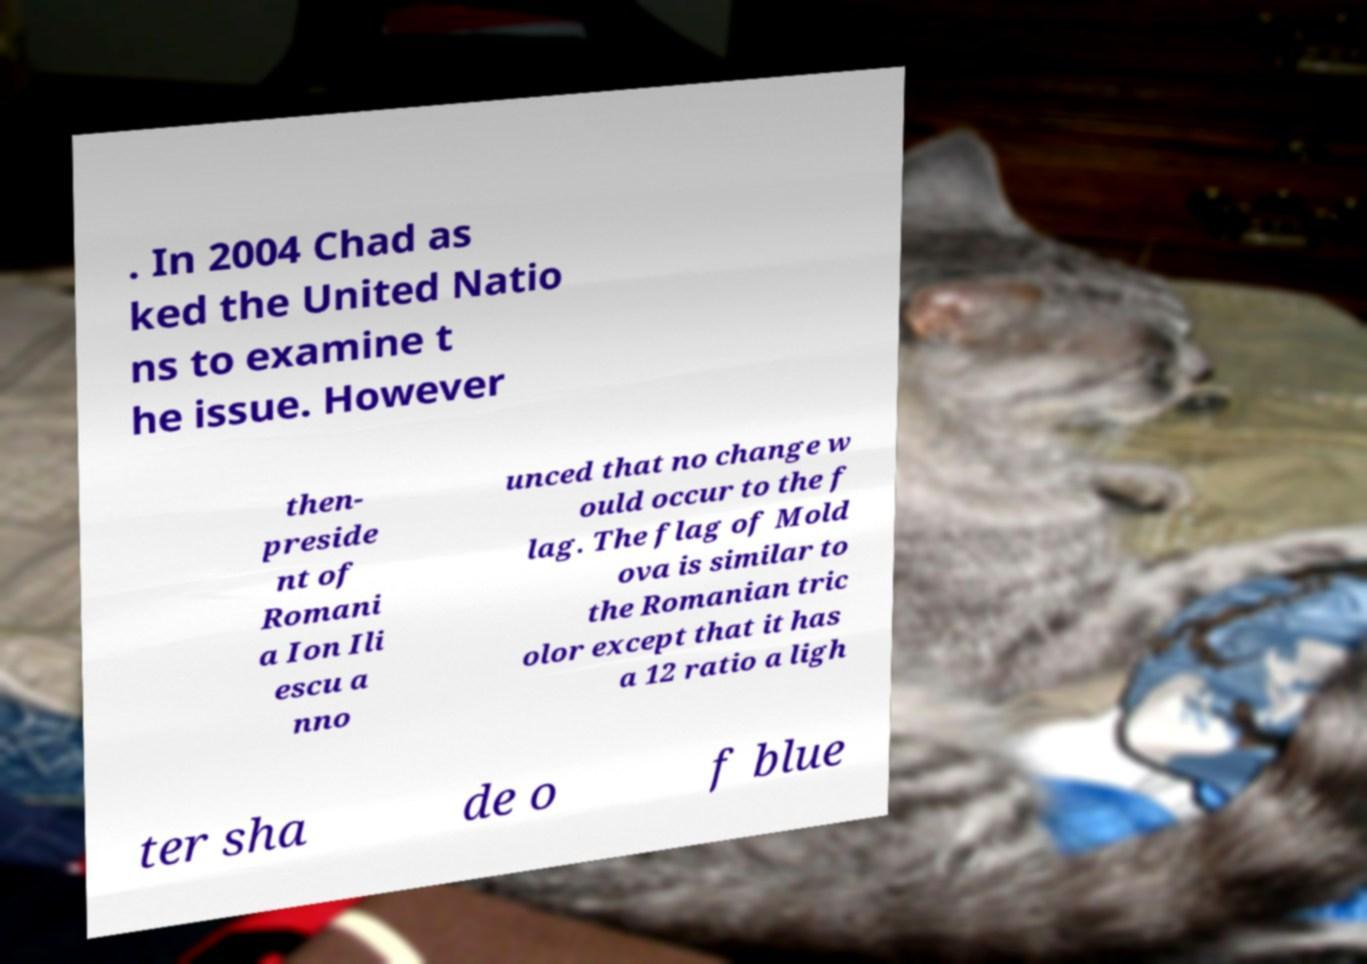What messages or text are displayed in this image? I need them in a readable, typed format. . In 2004 Chad as ked the United Natio ns to examine t he issue. However then- preside nt of Romani a Ion Ili escu a nno unced that no change w ould occur to the f lag. The flag of Mold ova is similar to the Romanian tric olor except that it has a 12 ratio a ligh ter sha de o f blue 